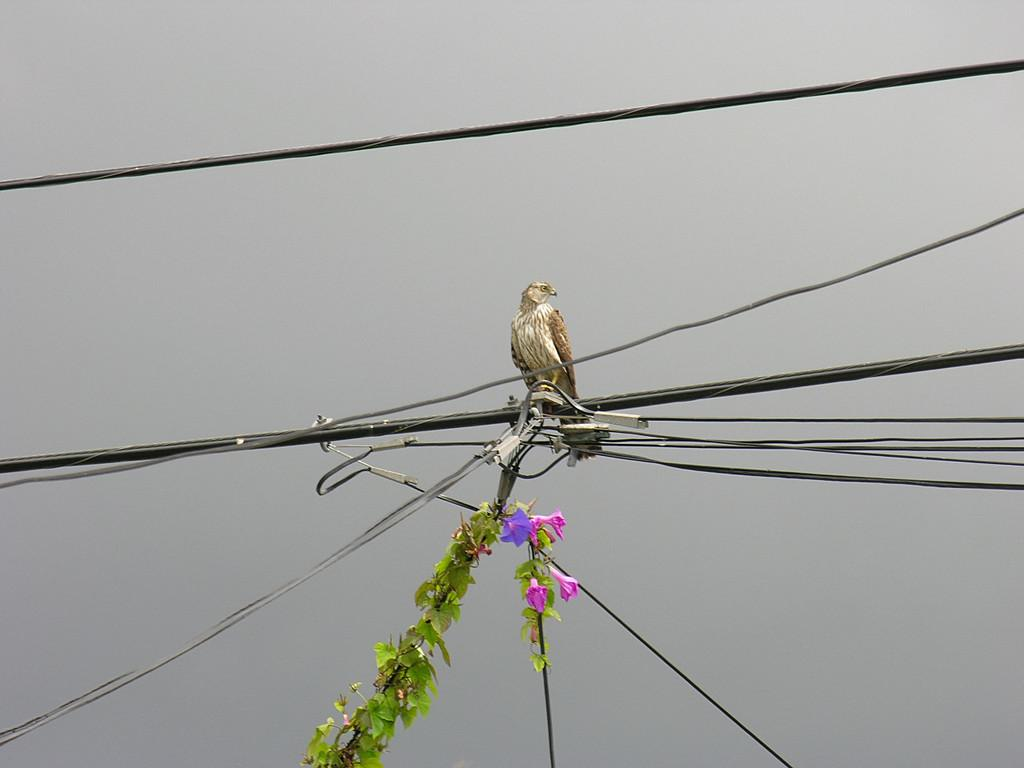What type of bird can be seen in the image? There is a white and brown color bird in the image. Where is the bird located? The bird is on a wire. What else can be seen in the image besides the bird? There are wires, leaves, pink color flowers, and the sky visible in the image. What advice does the bird give to the kitty in the image? There is no kitty present in the image, so the bird cannot give any advice to it. 